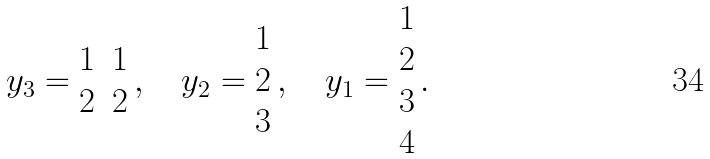<formula> <loc_0><loc_0><loc_500><loc_500>y _ { 3 } = \begin{matrix} 1 & 1 \\ 2 & 2 \end{matrix} \, , \quad y _ { 2 } = \begin{matrix} 1 \\ 2 \\ 3 \end{matrix} \, , \quad y _ { 1 } = \begin{matrix} 1 \\ 2 \\ 3 \\ 4 \end{matrix} \, .</formula> 